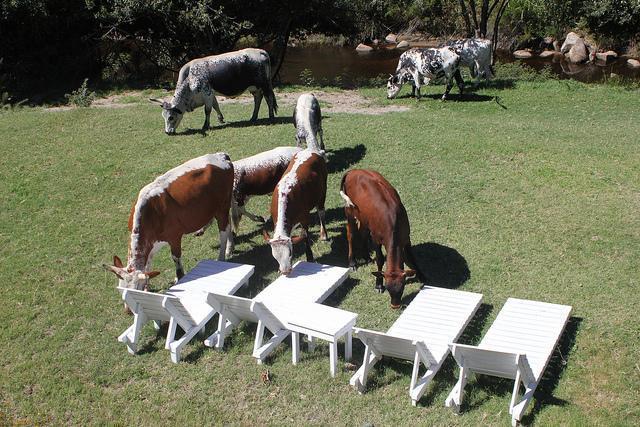What are the animals near?
Answer the question by selecting the correct answer among the 4 following choices and explain your choice with a short sentence. The answer should be formatted with the following format: `Answer: choice
Rationale: rationale.`
Options: Cars, apple trees, baby carriages, chairs. Answer: chairs.
Rationale: There are white chairs around the animals. 